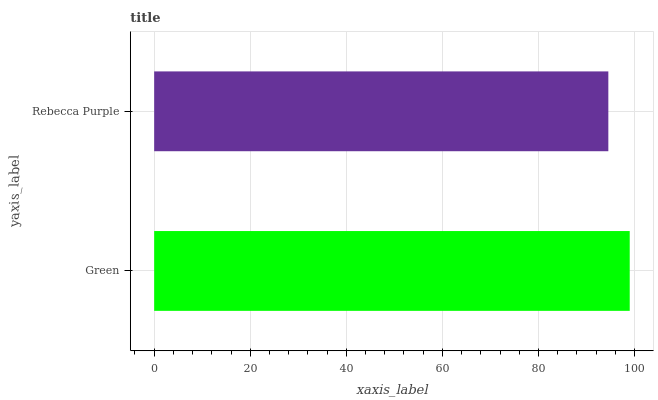Is Rebecca Purple the minimum?
Answer yes or no. Yes. Is Green the maximum?
Answer yes or no. Yes. Is Rebecca Purple the maximum?
Answer yes or no. No. Is Green greater than Rebecca Purple?
Answer yes or no. Yes. Is Rebecca Purple less than Green?
Answer yes or no. Yes. Is Rebecca Purple greater than Green?
Answer yes or no. No. Is Green less than Rebecca Purple?
Answer yes or no. No. Is Green the high median?
Answer yes or no. Yes. Is Rebecca Purple the low median?
Answer yes or no. Yes. Is Rebecca Purple the high median?
Answer yes or no. No. Is Green the low median?
Answer yes or no. No. 